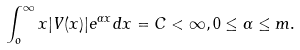Convert formula to latex. <formula><loc_0><loc_0><loc_500><loc_500>\int _ { o } ^ { \infty } x | V ( x ) | e ^ { \alpha x } d x = C < \infty , 0 \leq \alpha \leq m .</formula> 